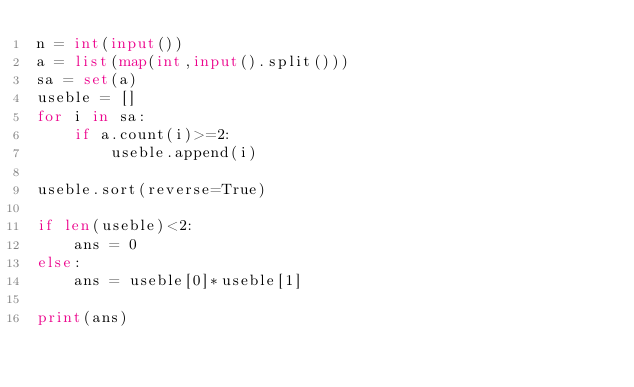<code> <loc_0><loc_0><loc_500><loc_500><_Python_>n = int(input())
a = list(map(int,input().split()))
sa = set(a)
useble = []
for i in sa:
    if a.count(i)>=2:
        useble.append(i)

useble.sort(reverse=True)

if len(useble)<2:
    ans = 0
else:
    ans = useble[0]*useble[1]

print(ans)
</code> 